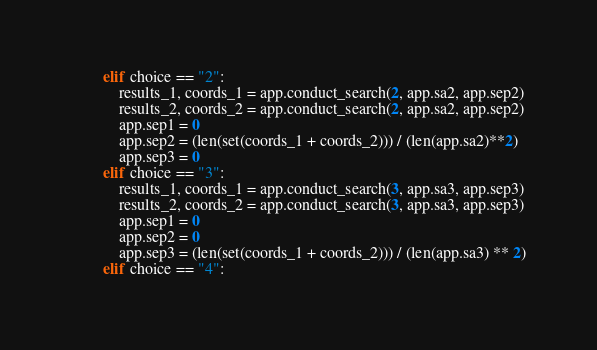Convert code to text. <code><loc_0><loc_0><loc_500><loc_500><_Python_>        elif choice == "2":
            results_1, coords_1 = app.conduct_search(2, app.sa2, app.sep2)
            results_2, coords_2 = app.conduct_search(2, app.sa2, app.sep2)
            app.sep1 = 0
            app.sep2 = (len(set(coords_1 + coords_2))) / (len(app.sa2)**2)
            app.sep3 = 0
        elif choice == "3":
            results_1, coords_1 = app.conduct_search(3, app.sa3, app.sep3)
            results_2, coords_2 = app.conduct_search(3, app.sa3, app.sep3)
            app.sep1 = 0
            app.sep2 = 0
            app.sep3 = (len(set(coords_1 + coords_2))) / (len(app.sa3) ** 2)
        elif choice == "4":</code> 